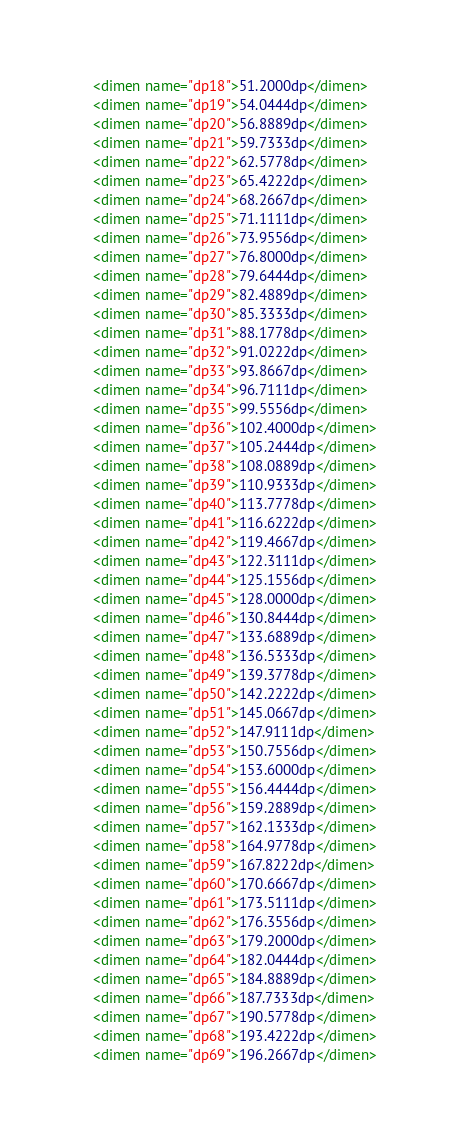Convert code to text. <code><loc_0><loc_0><loc_500><loc_500><_XML_>	<dimen name="dp18">51.2000dp</dimen>
	<dimen name="dp19">54.0444dp</dimen>
	<dimen name="dp20">56.8889dp</dimen>
	<dimen name="dp21">59.7333dp</dimen>
	<dimen name="dp22">62.5778dp</dimen>
	<dimen name="dp23">65.4222dp</dimen>
	<dimen name="dp24">68.2667dp</dimen>
	<dimen name="dp25">71.1111dp</dimen>
	<dimen name="dp26">73.9556dp</dimen>
	<dimen name="dp27">76.8000dp</dimen>
	<dimen name="dp28">79.6444dp</dimen>
	<dimen name="dp29">82.4889dp</dimen>
	<dimen name="dp30">85.3333dp</dimen>
	<dimen name="dp31">88.1778dp</dimen>
	<dimen name="dp32">91.0222dp</dimen>
	<dimen name="dp33">93.8667dp</dimen>
	<dimen name="dp34">96.7111dp</dimen>
	<dimen name="dp35">99.5556dp</dimen>
	<dimen name="dp36">102.4000dp</dimen>
	<dimen name="dp37">105.2444dp</dimen>
	<dimen name="dp38">108.0889dp</dimen>
	<dimen name="dp39">110.9333dp</dimen>
	<dimen name="dp40">113.7778dp</dimen>
	<dimen name="dp41">116.6222dp</dimen>
	<dimen name="dp42">119.4667dp</dimen>
	<dimen name="dp43">122.3111dp</dimen>
	<dimen name="dp44">125.1556dp</dimen>
	<dimen name="dp45">128.0000dp</dimen>
	<dimen name="dp46">130.8444dp</dimen>
	<dimen name="dp47">133.6889dp</dimen>
	<dimen name="dp48">136.5333dp</dimen>
	<dimen name="dp49">139.3778dp</dimen>
	<dimen name="dp50">142.2222dp</dimen>
	<dimen name="dp51">145.0667dp</dimen>
	<dimen name="dp52">147.9111dp</dimen>
	<dimen name="dp53">150.7556dp</dimen>
	<dimen name="dp54">153.6000dp</dimen>
	<dimen name="dp55">156.4444dp</dimen>
	<dimen name="dp56">159.2889dp</dimen>
	<dimen name="dp57">162.1333dp</dimen>
	<dimen name="dp58">164.9778dp</dimen>
	<dimen name="dp59">167.8222dp</dimen>
	<dimen name="dp60">170.6667dp</dimen>
	<dimen name="dp61">173.5111dp</dimen>
	<dimen name="dp62">176.3556dp</dimen>
	<dimen name="dp63">179.2000dp</dimen>
	<dimen name="dp64">182.0444dp</dimen>
	<dimen name="dp65">184.8889dp</dimen>
	<dimen name="dp66">187.7333dp</dimen>
	<dimen name="dp67">190.5778dp</dimen>
	<dimen name="dp68">193.4222dp</dimen>
	<dimen name="dp69">196.2667dp</dimen></code> 